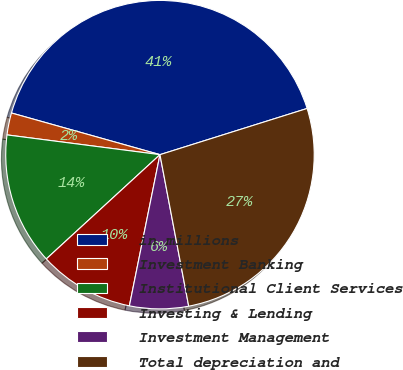Convert chart to OTSL. <chart><loc_0><loc_0><loc_500><loc_500><pie_chart><fcel>in millions<fcel>Investment Banking<fcel>Institutional Client Services<fcel>Investing & Lending<fcel>Investment Management<fcel>Total depreciation and<nl><fcel>40.81%<fcel>2.31%<fcel>13.86%<fcel>10.01%<fcel>6.16%<fcel>26.86%<nl></chart> 